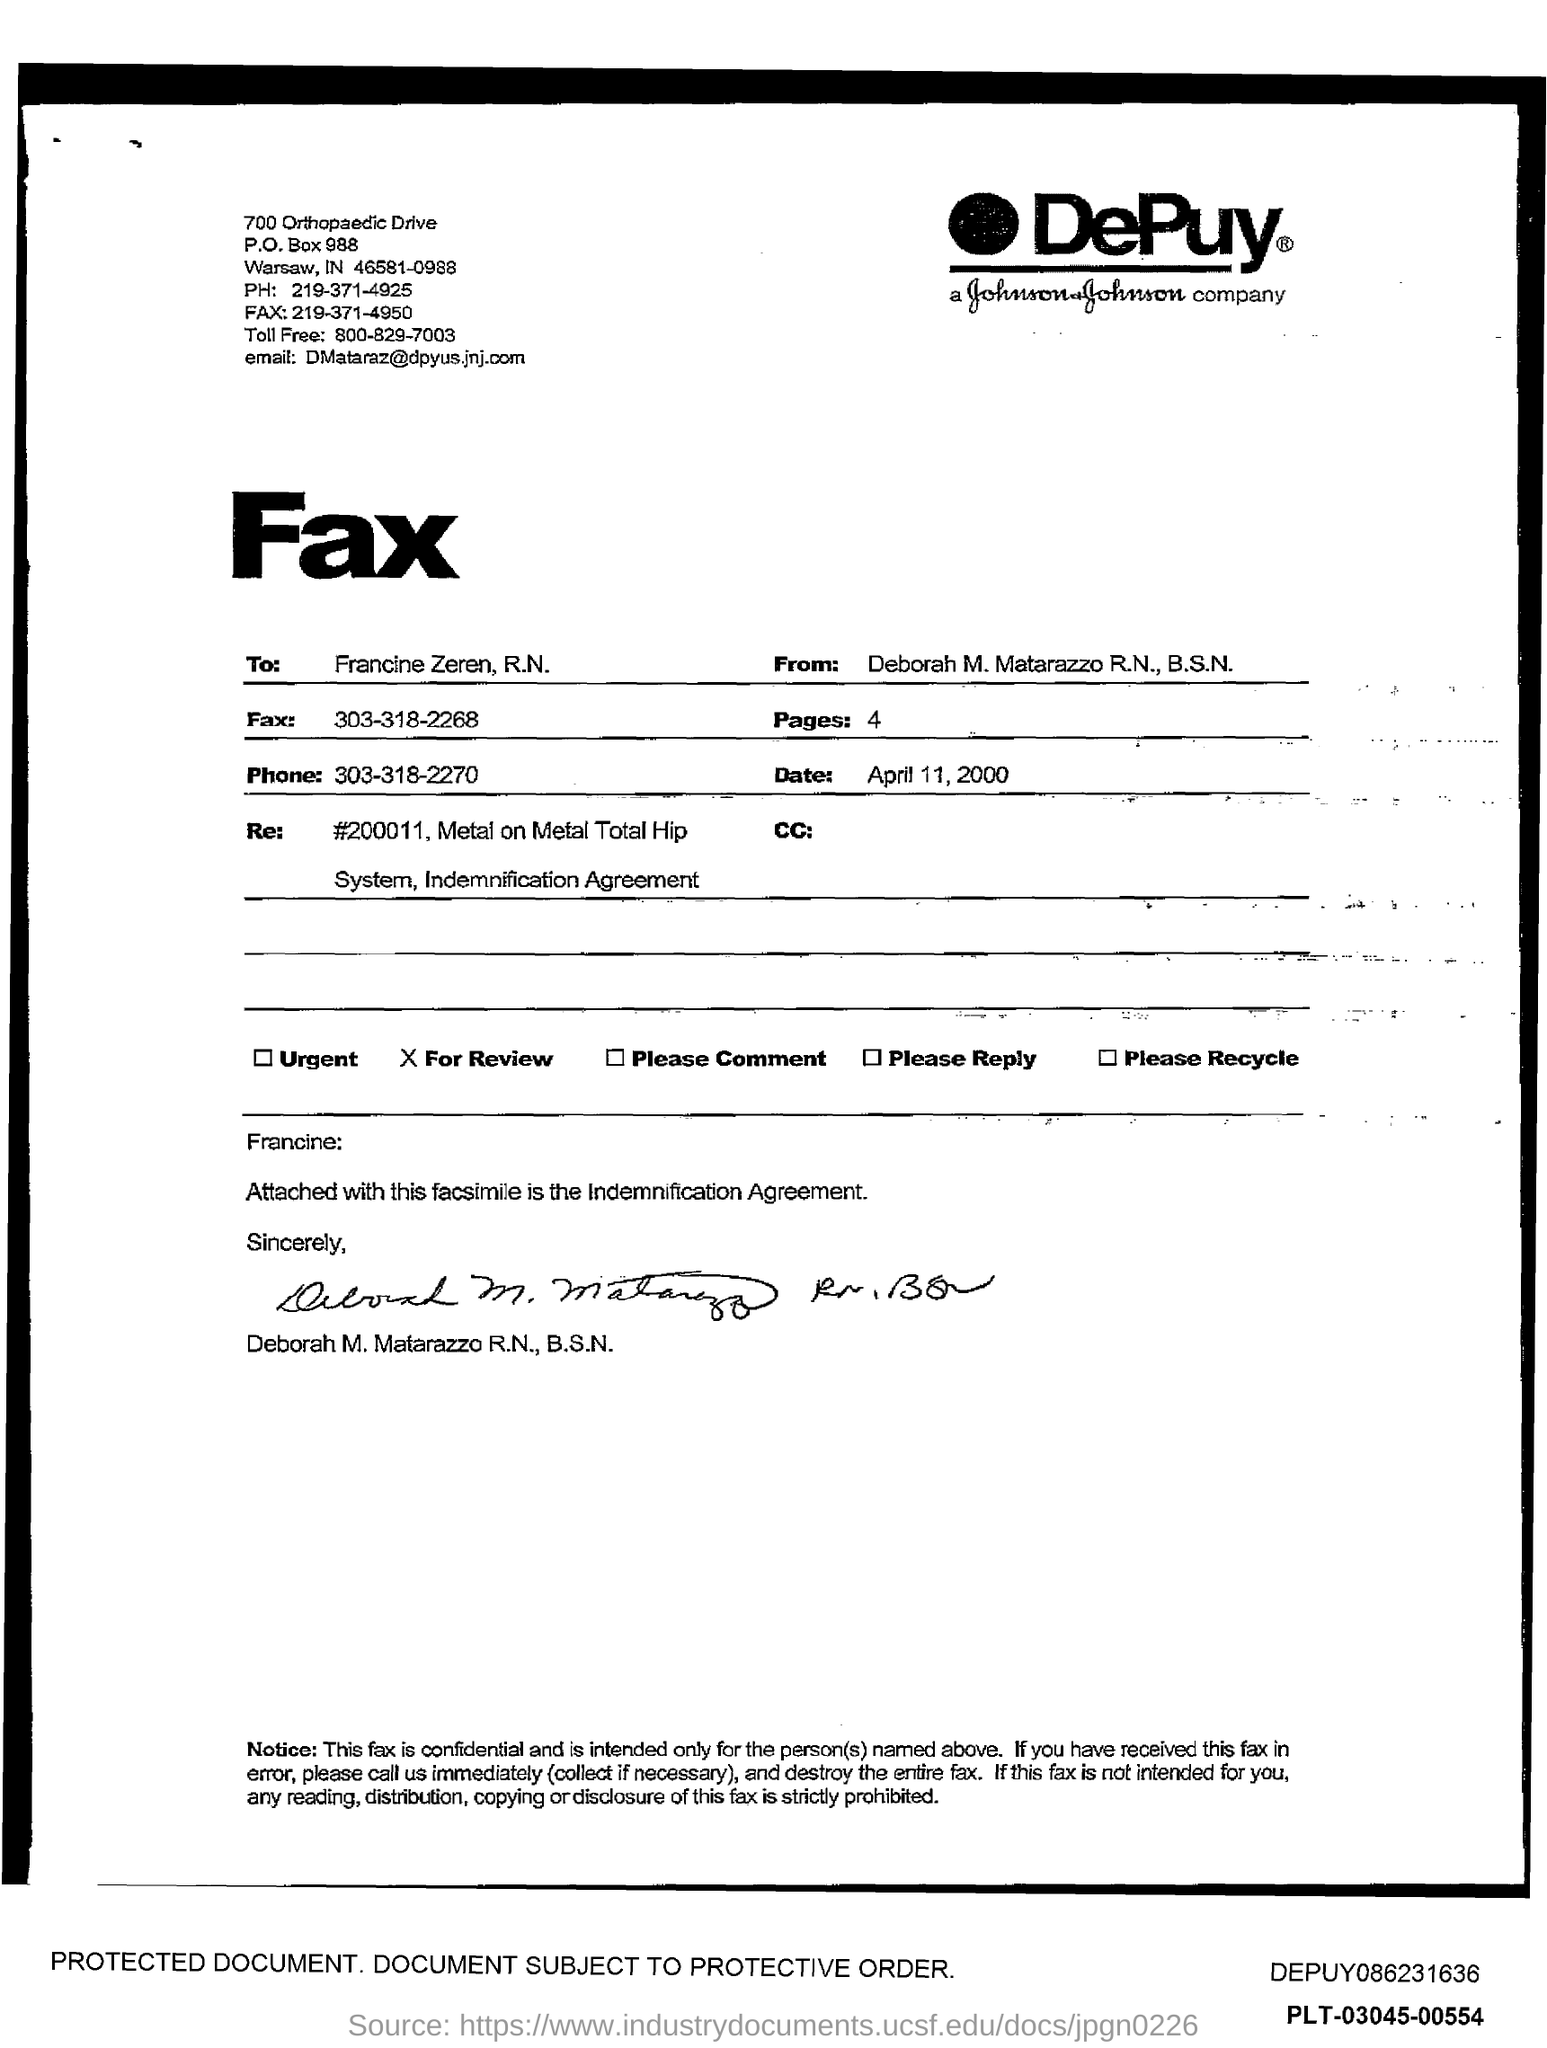Specify some key components in this picture. The fax is a communication method that sends documents as images over telephone lines, and the phone number provided is 303-318-2268. The fax is addressed to Francine Zeren, R.N. The phone number is 303-318-2270. I have determined that there are 4 pages. 